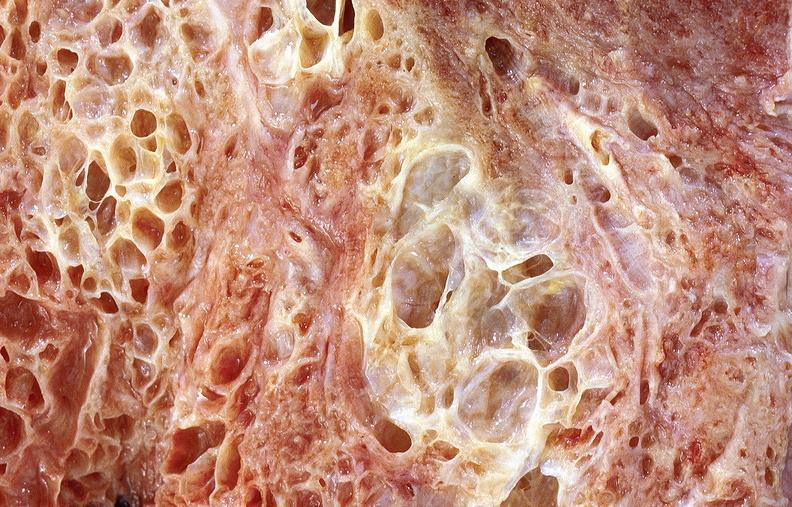does this image show lung fibrosis, scleroderma?
Answer the question using a single word or phrase. Yes 